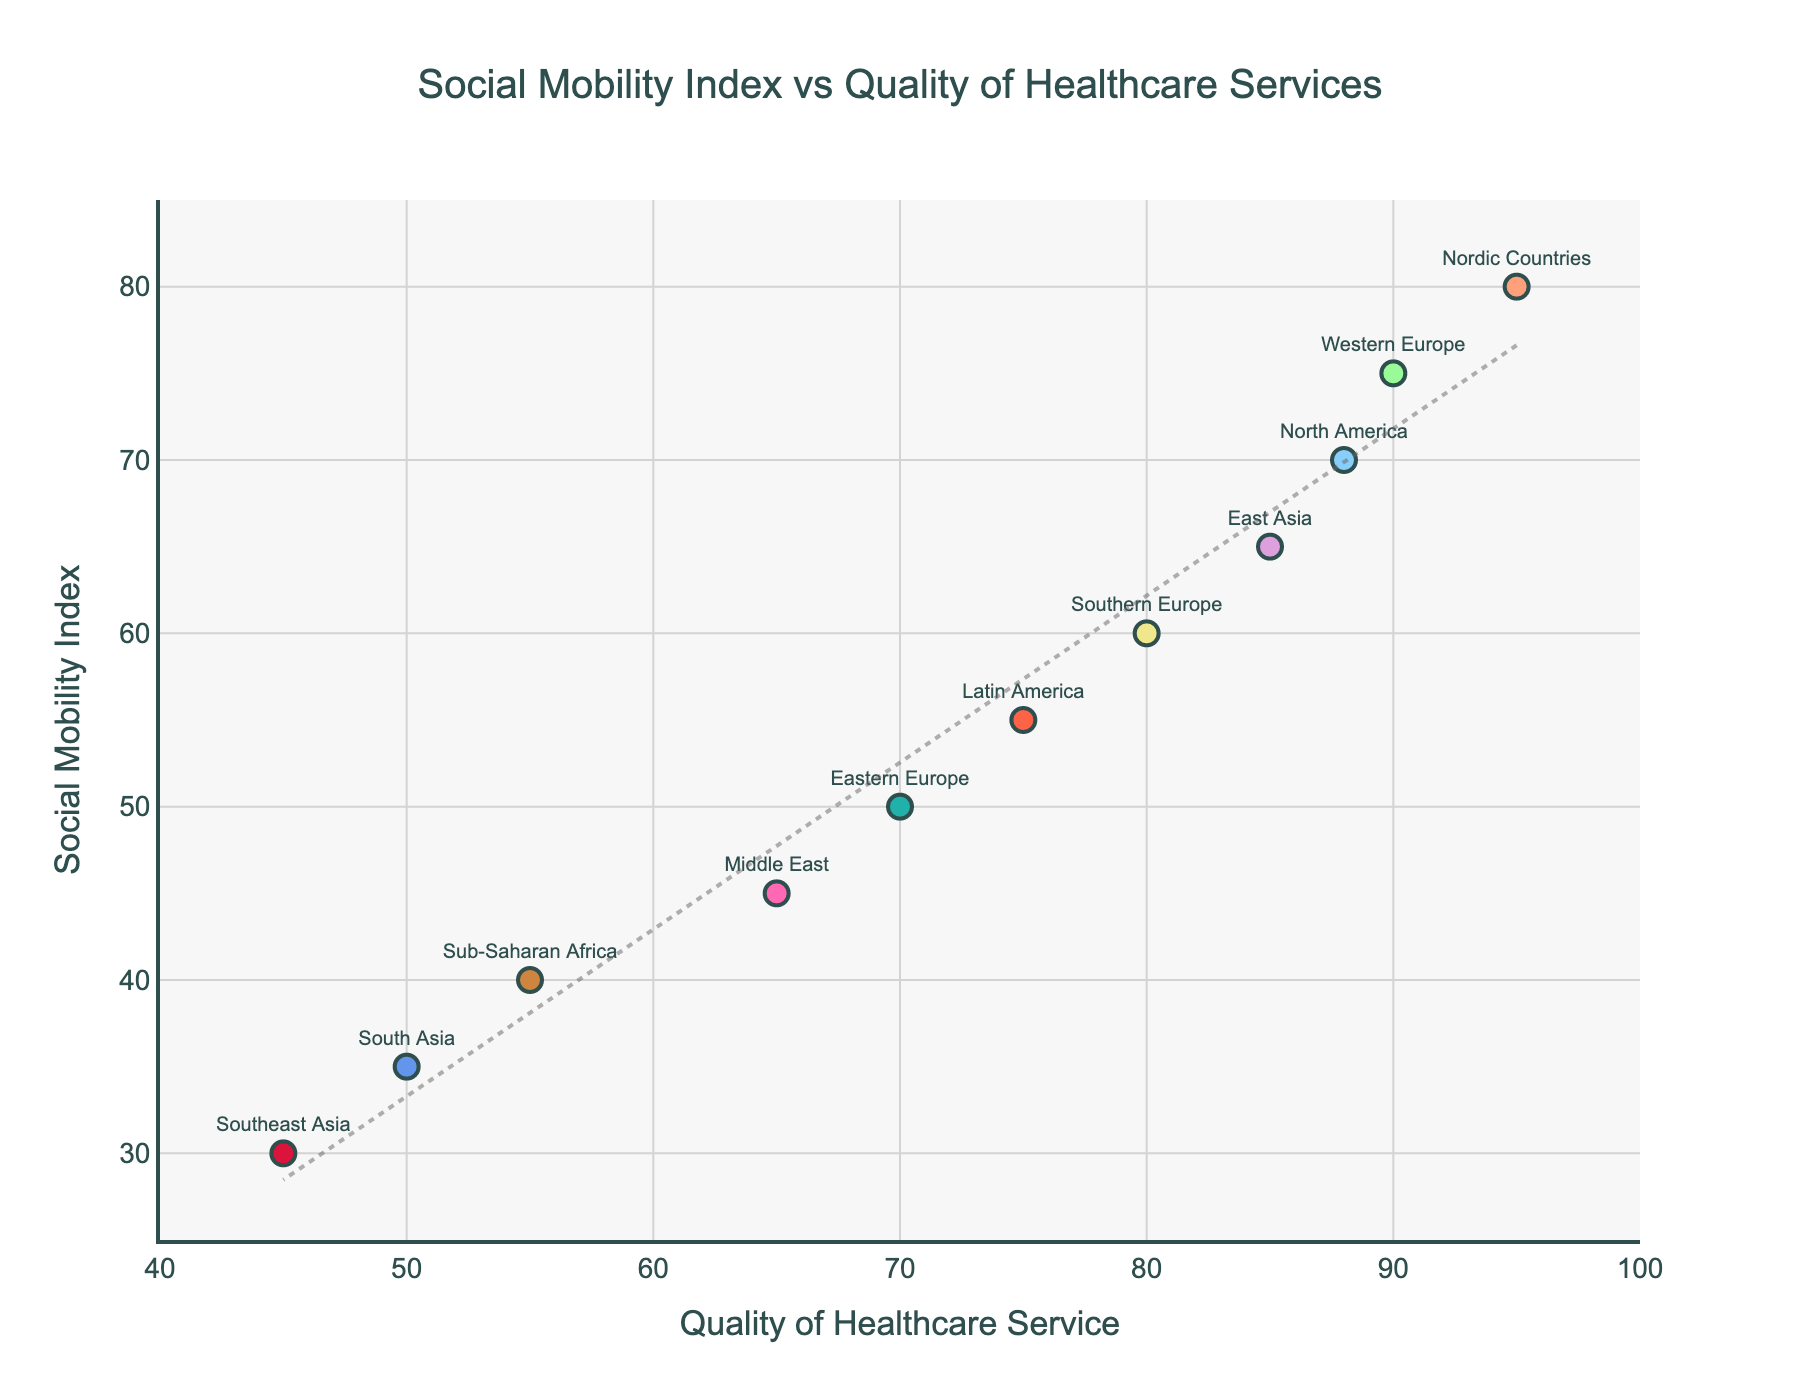What's the title of the scatter plot? The title of the scatter plot is placed at the top and is in larger, bold font for easy identification.
Answer: Social Mobility Index vs Quality of Healthcare Services What are the labels for the x-axis and y-axis? The x-axis label is positioned horizontally at the bottom of the plot, and the y-axis label is vertically aligned on the left side of the plot.
Answer: Quality of Healthcare Service (x-axis), Social Mobility Index (y-axis) Which region has the highest Social Mobility Index? By locating the data point highest on the y-axis representing the Social Mobility Index and noting its label, you can identify the region.
Answer: Nordic Countries Is there a visible trend between Social Mobility Index and Quality of Healthcare Services? The trend can be determined by analyzing the scatter plot and the presence of a trend line (typically represented by a line going up or down across the plot).
Answer: Yes, a positive trend What range does the Social Mobility Index span in this plot? Observe the lowest and highest points on the y-axis to determine the range of the Social Mobility Index values.
Answer: 30 to 80 How does the Social Mobility Index of North America compare to East Asia? Identify and note the y-axis positions of the data points labeled North America and East Asia, then compare their values.
Answer: North America is higher Which region has the lowest quality of healthcare services? The region with the lowest quality of healthcare service will be at the farthest left point on the x-axis.
Answer: Southeast Asia What is the difference in Social Mobility Index between Southern Europe and Latin America? Find the y-axis values for Southern Europe and Latin America and subtract the smaller value from the larger one.
Answer: 5 Which two regions have a Quality of Healthcare Service value of 70 and 80 respectively? Locate the points on the x-axis at 70 and 80 and identify the regions labeled at these points.
Answer: Eastern Europe and Southern Europe Between which two regions is the gap in Quality of Healthcare Services largest? Quantify the horizontal distance between each pair of regions and identify the pair with the largest gap.
Answer: Sub-Saharan Africa and Nordic Countries 